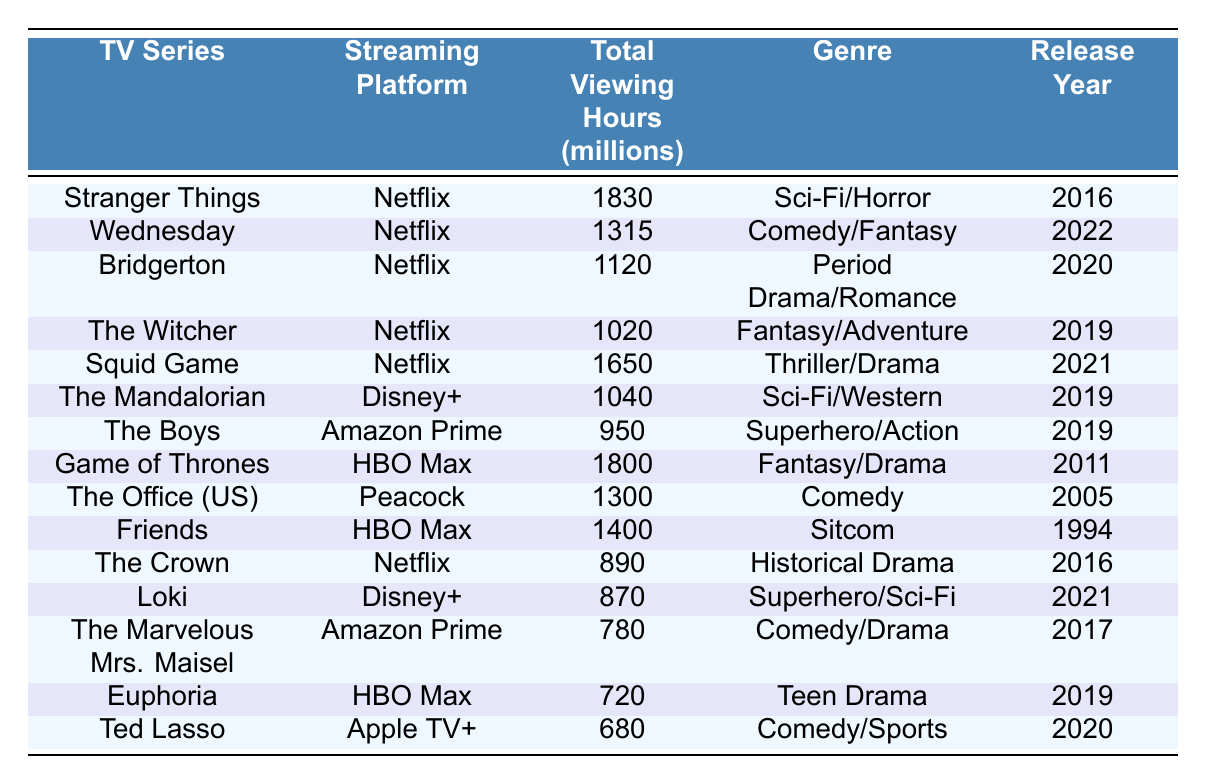What is the TV series with the highest total viewing hours? The table shows "Stranger Things" with 1830 million total viewing hours, which is the highest value in the column.
Answer: Stranger Things Which streaming platform has the most series listed in this table? The table displays multiple series, and all of them except for one are from Netflix. Therefore, Netflix has the most series listed.
Answer: Netflix What genre does "The Mandalorian" belong to? Looking at the genre column of the table, "The Mandalorian" is classified as Sci-Fi/Western.
Answer: Sci-Fi/Western How many viewing hours does "Friends" have compared to "Euphoria"? "Friends" has 1400 million total viewing hours, while "Euphoria" has 720 million. The difference is 1400 - 720 = 680 million hours.
Answer: 680 million Which series was released first: "The Witcher" or "Bridgerton"? Checking the release years in the table, "The Witcher" was released in 2019, and "Bridgerton" was released in 2020, making "The Witcher" the earlier series.
Answer: The Witcher What is the total viewing hours of all Netflix series combined? The Netflix series listed are "Stranger Things" (1830), "Wednesday" (1315), "Bridgerton" (1120), "The Witcher" (1020), "Squid Game" (1650), and "The Crown" (890). The sum is 1830 + 1315 + 1120 + 1020 + 1650 + 890 = 6835 million hours.
Answer: 6835 million Is "Euphoria" a Comedy or a Teen Drama? The genre listed for "Euphoria" in the table is Teen Drama, confirming it is not a Comedy.
Answer: No Which series has the least total viewing hours? In the table, "Ted Lasso" has 680 million total viewing hours, which is the lowest value compared to the others.
Answer: Ted Lasso What percentage of the total viewing hours does "Loki" represent among the series listed? First, sum up all the total viewing hours: 1830 + 1315 + 1120 + 1020 + 1650 + 1040 + 950 + 1800 + 1300 + 1400 + 890 + 870 + 780 + 720 + 680 = 10790 million hours. Loki has 870 million. The percentage is (870/10790) * 100 = approximately 8.06%.
Answer: 8.06% Which series has a genre that combines Superhero and Sci-Fi themes? Looking at the genre column, "Loki" is classified under Superhero/Sci-Fi, fitting the description.
Answer: Loki 